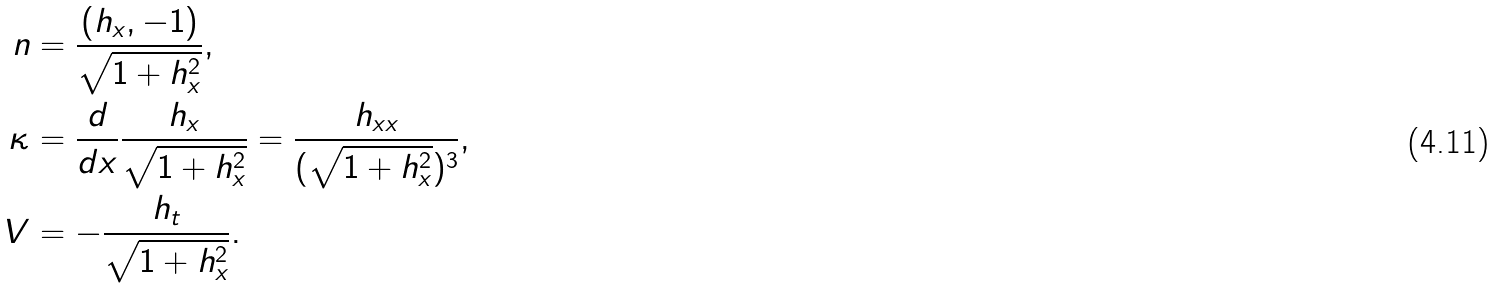<formula> <loc_0><loc_0><loc_500><loc_500>n & = \frac { ( h _ { x } , - 1 ) } { \sqrt { 1 + h _ { x } ^ { 2 } } } , \\ \kappa & = \frac { d } { d x } \frac { h _ { x } } { \sqrt { 1 + h _ { x } ^ { 2 } } } = \frac { h _ { x x } } { ( \sqrt { 1 + h _ { x } ^ { 2 } } ) ^ { 3 } } , \\ V & = - \frac { h _ { t } } { \sqrt { 1 + h _ { x } ^ { 2 } } } .</formula> 